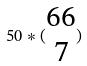<formula> <loc_0><loc_0><loc_500><loc_500>5 0 * ( \begin{matrix} 6 6 \\ 7 \end{matrix} )</formula> 